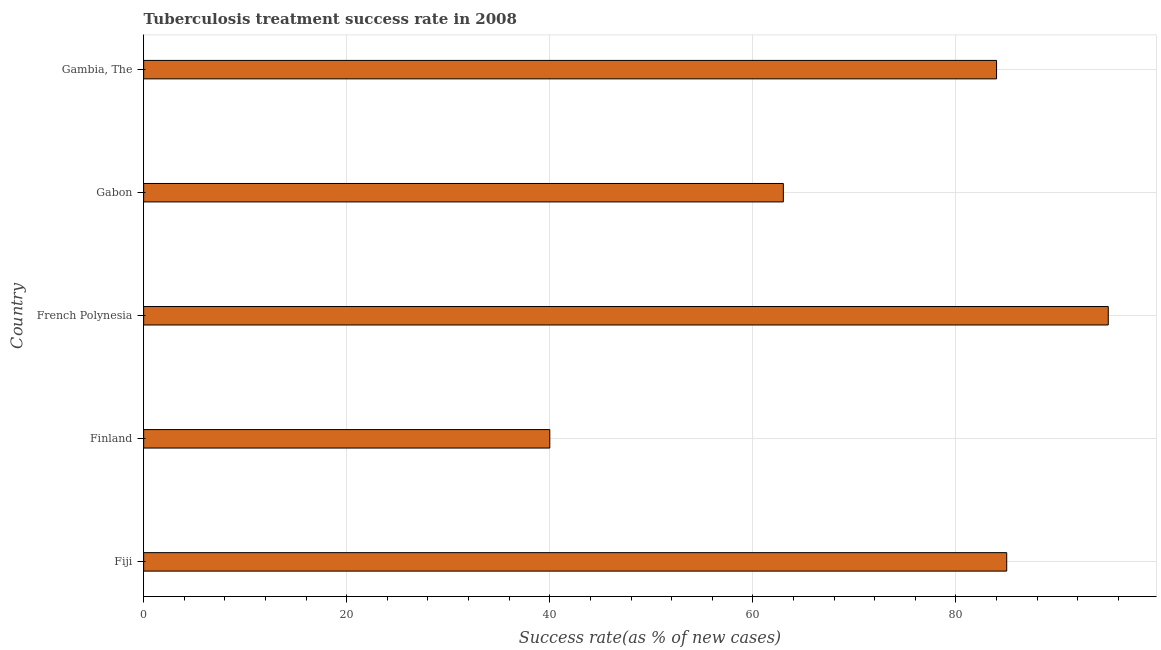Does the graph contain any zero values?
Provide a succinct answer. No. Does the graph contain grids?
Provide a short and direct response. Yes. What is the title of the graph?
Keep it short and to the point. Tuberculosis treatment success rate in 2008. What is the label or title of the X-axis?
Provide a short and direct response. Success rate(as % of new cases). What is the tuberculosis treatment success rate in Gabon?
Provide a short and direct response. 63. Across all countries, what is the maximum tuberculosis treatment success rate?
Your answer should be compact. 95. Across all countries, what is the minimum tuberculosis treatment success rate?
Your answer should be very brief. 40. In which country was the tuberculosis treatment success rate maximum?
Give a very brief answer. French Polynesia. What is the sum of the tuberculosis treatment success rate?
Provide a succinct answer. 367. What is the difference between the tuberculosis treatment success rate in Finland and French Polynesia?
Make the answer very short. -55. What is the average tuberculosis treatment success rate per country?
Make the answer very short. 73. What is the ratio of the tuberculosis treatment success rate in Fiji to that in Gabon?
Make the answer very short. 1.35. Is the difference between the tuberculosis treatment success rate in Fiji and French Polynesia greater than the difference between any two countries?
Your answer should be compact. No. What is the difference between the highest and the lowest tuberculosis treatment success rate?
Your answer should be compact. 55. How many bars are there?
Ensure brevity in your answer.  5. Are all the bars in the graph horizontal?
Give a very brief answer. Yes. What is the difference between two consecutive major ticks on the X-axis?
Provide a short and direct response. 20. What is the Success rate(as % of new cases) in French Polynesia?
Offer a very short reply. 95. What is the difference between the Success rate(as % of new cases) in Finland and French Polynesia?
Your answer should be compact. -55. What is the difference between the Success rate(as % of new cases) in Finland and Gabon?
Your answer should be very brief. -23. What is the difference between the Success rate(as % of new cases) in Finland and Gambia, The?
Provide a succinct answer. -44. What is the difference between the Success rate(as % of new cases) in French Polynesia and Gambia, The?
Your answer should be compact. 11. What is the difference between the Success rate(as % of new cases) in Gabon and Gambia, The?
Offer a very short reply. -21. What is the ratio of the Success rate(as % of new cases) in Fiji to that in Finland?
Your response must be concise. 2.12. What is the ratio of the Success rate(as % of new cases) in Fiji to that in French Polynesia?
Ensure brevity in your answer.  0.9. What is the ratio of the Success rate(as % of new cases) in Fiji to that in Gabon?
Your answer should be very brief. 1.35. What is the ratio of the Success rate(as % of new cases) in Fiji to that in Gambia, The?
Make the answer very short. 1.01. What is the ratio of the Success rate(as % of new cases) in Finland to that in French Polynesia?
Provide a succinct answer. 0.42. What is the ratio of the Success rate(as % of new cases) in Finland to that in Gabon?
Ensure brevity in your answer.  0.64. What is the ratio of the Success rate(as % of new cases) in Finland to that in Gambia, The?
Ensure brevity in your answer.  0.48. What is the ratio of the Success rate(as % of new cases) in French Polynesia to that in Gabon?
Offer a terse response. 1.51. What is the ratio of the Success rate(as % of new cases) in French Polynesia to that in Gambia, The?
Your response must be concise. 1.13. 